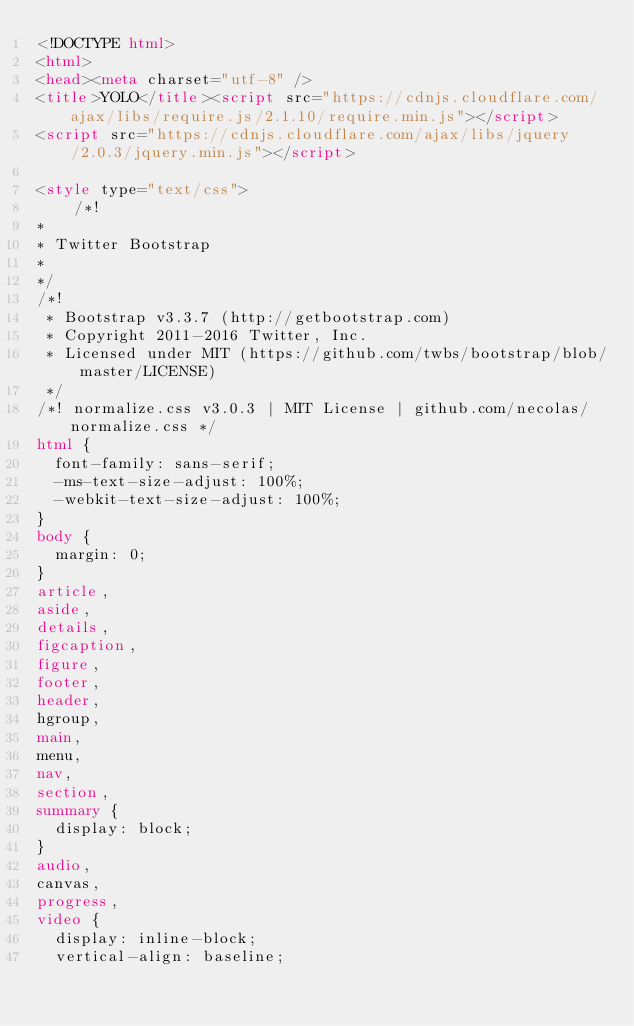Convert code to text. <code><loc_0><loc_0><loc_500><loc_500><_HTML_><!DOCTYPE html>
<html>
<head><meta charset="utf-8" />
<title>YOLO</title><script src="https://cdnjs.cloudflare.com/ajax/libs/require.js/2.1.10/require.min.js"></script>
<script src="https://cdnjs.cloudflare.com/ajax/libs/jquery/2.0.3/jquery.min.js"></script>

<style type="text/css">
    /*!
*
* Twitter Bootstrap
*
*/
/*!
 * Bootstrap v3.3.7 (http://getbootstrap.com)
 * Copyright 2011-2016 Twitter, Inc.
 * Licensed under MIT (https://github.com/twbs/bootstrap/blob/master/LICENSE)
 */
/*! normalize.css v3.0.3 | MIT License | github.com/necolas/normalize.css */
html {
  font-family: sans-serif;
  -ms-text-size-adjust: 100%;
  -webkit-text-size-adjust: 100%;
}
body {
  margin: 0;
}
article,
aside,
details,
figcaption,
figure,
footer,
header,
hgroup,
main,
menu,
nav,
section,
summary {
  display: block;
}
audio,
canvas,
progress,
video {
  display: inline-block;
  vertical-align: baseline;</code> 